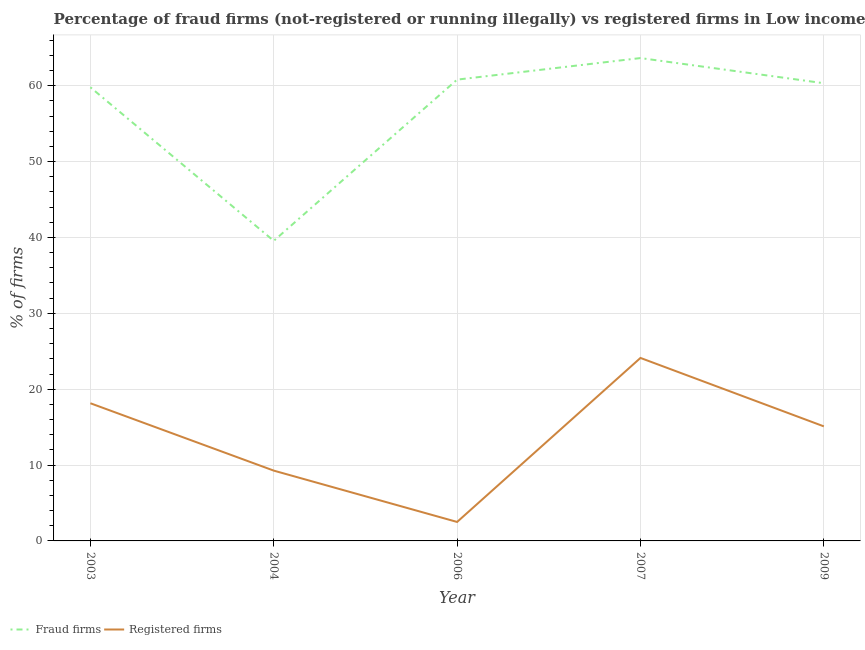How many different coloured lines are there?
Ensure brevity in your answer.  2. Does the line corresponding to percentage of registered firms intersect with the line corresponding to percentage of fraud firms?
Your answer should be compact. No. Across all years, what is the maximum percentage of registered firms?
Your response must be concise. 24.12. Across all years, what is the minimum percentage of fraud firms?
Provide a short and direct response. 39.55. In which year was the percentage of fraud firms maximum?
Provide a succinct answer. 2007. What is the total percentage of fraud firms in the graph?
Keep it short and to the point. 284.1. What is the difference between the percentage of fraud firms in 2003 and that in 2007?
Your response must be concise. -3.85. What is the difference between the percentage of fraud firms in 2004 and the percentage of registered firms in 2006?
Your answer should be compact. 37.05. What is the average percentage of fraud firms per year?
Make the answer very short. 56.82. In the year 2004, what is the difference between the percentage of registered firms and percentage of fraud firms?
Your answer should be very brief. -30.28. What is the ratio of the percentage of fraud firms in 2006 to that in 2007?
Make the answer very short. 0.96. Is the difference between the percentage of registered firms in 2004 and 2007 greater than the difference between the percentage of fraud firms in 2004 and 2007?
Your answer should be compact. Yes. What is the difference between the highest and the second highest percentage of registered firms?
Provide a short and direct response. 5.97. What is the difference between the highest and the lowest percentage of fraud firms?
Offer a very short reply. 24.09. Is the sum of the percentage of registered firms in 2004 and 2006 greater than the maximum percentage of fraud firms across all years?
Offer a very short reply. No. Does the percentage of registered firms monotonically increase over the years?
Your answer should be very brief. No. How many years are there in the graph?
Your response must be concise. 5. What is the difference between two consecutive major ticks on the Y-axis?
Your response must be concise. 10. Are the values on the major ticks of Y-axis written in scientific E-notation?
Offer a very short reply. No. How many legend labels are there?
Provide a short and direct response. 2. What is the title of the graph?
Provide a short and direct response. Percentage of fraud firms (not-registered or running illegally) vs registered firms in Low income. What is the label or title of the Y-axis?
Provide a short and direct response. % of firms. What is the % of firms of Fraud firms in 2003?
Provide a short and direct response. 59.79. What is the % of firms of Registered firms in 2003?
Offer a terse response. 18.15. What is the % of firms in Fraud firms in 2004?
Ensure brevity in your answer.  39.55. What is the % of firms of Registered firms in 2004?
Provide a succinct answer. 9.27. What is the % of firms in Fraud firms in 2006?
Your answer should be very brief. 60.8. What is the % of firms of Registered firms in 2006?
Your answer should be compact. 2.5. What is the % of firms of Fraud firms in 2007?
Offer a terse response. 63.64. What is the % of firms in Registered firms in 2007?
Your response must be concise. 24.12. What is the % of firms in Fraud firms in 2009?
Your answer should be very brief. 60.33. What is the % of firms of Registered firms in 2009?
Make the answer very short. 15.1. Across all years, what is the maximum % of firms of Fraud firms?
Your answer should be very brief. 63.64. Across all years, what is the maximum % of firms of Registered firms?
Provide a succinct answer. 24.12. Across all years, what is the minimum % of firms of Fraud firms?
Give a very brief answer. 39.55. Across all years, what is the minimum % of firms in Registered firms?
Ensure brevity in your answer.  2.5. What is the total % of firms of Fraud firms in the graph?
Your answer should be very brief. 284.1. What is the total % of firms of Registered firms in the graph?
Your response must be concise. 69.13. What is the difference between the % of firms in Fraud firms in 2003 and that in 2004?
Provide a succinct answer. 20.24. What is the difference between the % of firms of Registered firms in 2003 and that in 2004?
Make the answer very short. 8.88. What is the difference between the % of firms in Fraud firms in 2003 and that in 2006?
Provide a succinct answer. -1.01. What is the difference between the % of firms in Registered firms in 2003 and that in 2006?
Offer a very short reply. 15.65. What is the difference between the % of firms in Fraud firms in 2003 and that in 2007?
Your answer should be compact. -3.85. What is the difference between the % of firms of Registered firms in 2003 and that in 2007?
Give a very brief answer. -5.97. What is the difference between the % of firms in Fraud firms in 2003 and that in 2009?
Make the answer very short. -0.54. What is the difference between the % of firms of Registered firms in 2003 and that in 2009?
Offer a very short reply. 3.05. What is the difference between the % of firms in Fraud firms in 2004 and that in 2006?
Provide a succinct answer. -21.25. What is the difference between the % of firms of Registered firms in 2004 and that in 2006?
Your answer should be very brief. 6.77. What is the difference between the % of firms in Fraud firms in 2004 and that in 2007?
Provide a succinct answer. -24.09. What is the difference between the % of firms of Registered firms in 2004 and that in 2007?
Your answer should be compact. -14.85. What is the difference between the % of firms of Fraud firms in 2004 and that in 2009?
Provide a succinct answer. -20.77. What is the difference between the % of firms of Registered firms in 2004 and that in 2009?
Your answer should be compact. -5.83. What is the difference between the % of firms of Fraud firms in 2006 and that in 2007?
Make the answer very short. -2.84. What is the difference between the % of firms in Registered firms in 2006 and that in 2007?
Your response must be concise. -21.62. What is the difference between the % of firms in Fraud firms in 2006 and that in 2009?
Ensure brevity in your answer.  0.47. What is the difference between the % of firms in Registered firms in 2006 and that in 2009?
Give a very brief answer. -12.6. What is the difference between the % of firms in Fraud firms in 2007 and that in 2009?
Ensure brevity in your answer.  3.31. What is the difference between the % of firms in Registered firms in 2007 and that in 2009?
Your answer should be very brief. 9.02. What is the difference between the % of firms of Fraud firms in 2003 and the % of firms of Registered firms in 2004?
Ensure brevity in your answer.  50.52. What is the difference between the % of firms in Fraud firms in 2003 and the % of firms in Registered firms in 2006?
Provide a succinct answer. 57.29. What is the difference between the % of firms of Fraud firms in 2003 and the % of firms of Registered firms in 2007?
Your answer should be very brief. 35.67. What is the difference between the % of firms of Fraud firms in 2003 and the % of firms of Registered firms in 2009?
Provide a succinct answer. 44.69. What is the difference between the % of firms in Fraud firms in 2004 and the % of firms in Registered firms in 2006?
Your answer should be very brief. 37.05. What is the difference between the % of firms of Fraud firms in 2004 and the % of firms of Registered firms in 2007?
Make the answer very short. 15.43. What is the difference between the % of firms of Fraud firms in 2004 and the % of firms of Registered firms in 2009?
Make the answer very short. 24.45. What is the difference between the % of firms of Fraud firms in 2006 and the % of firms of Registered firms in 2007?
Provide a short and direct response. 36.68. What is the difference between the % of firms of Fraud firms in 2006 and the % of firms of Registered firms in 2009?
Your answer should be very brief. 45.7. What is the difference between the % of firms in Fraud firms in 2007 and the % of firms in Registered firms in 2009?
Provide a short and direct response. 48.54. What is the average % of firms in Fraud firms per year?
Your response must be concise. 56.82. What is the average % of firms in Registered firms per year?
Ensure brevity in your answer.  13.83. In the year 2003, what is the difference between the % of firms of Fraud firms and % of firms of Registered firms?
Your response must be concise. 41.64. In the year 2004, what is the difference between the % of firms of Fraud firms and % of firms of Registered firms?
Your answer should be compact. 30.28. In the year 2006, what is the difference between the % of firms of Fraud firms and % of firms of Registered firms?
Your answer should be very brief. 58.3. In the year 2007, what is the difference between the % of firms of Fraud firms and % of firms of Registered firms?
Provide a succinct answer. 39.52. In the year 2009, what is the difference between the % of firms of Fraud firms and % of firms of Registered firms?
Provide a succinct answer. 45.23. What is the ratio of the % of firms of Fraud firms in 2003 to that in 2004?
Keep it short and to the point. 1.51. What is the ratio of the % of firms of Registered firms in 2003 to that in 2004?
Give a very brief answer. 1.96. What is the ratio of the % of firms of Fraud firms in 2003 to that in 2006?
Give a very brief answer. 0.98. What is the ratio of the % of firms in Registered firms in 2003 to that in 2006?
Your answer should be compact. 7.26. What is the ratio of the % of firms of Fraud firms in 2003 to that in 2007?
Your response must be concise. 0.94. What is the ratio of the % of firms of Registered firms in 2003 to that in 2007?
Provide a succinct answer. 0.75. What is the ratio of the % of firms in Registered firms in 2003 to that in 2009?
Offer a terse response. 1.2. What is the ratio of the % of firms in Fraud firms in 2004 to that in 2006?
Keep it short and to the point. 0.65. What is the ratio of the % of firms of Registered firms in 2004 to that in 2006?
Keep it short and to the point. 3.71. What is the ratio of the % of firms of Fraud firms in 2004 to that in 2007?
Your response must be concise. 0.62. What is the ratio of the % of firms of Registered firms in 2004 to that in 2007?
Offer a very short reply. 0.38. What is the ratio of the % of firms in Fraud firms in 2004 to that in 2009?
Your answer should be very brief. 0.66. What is the ratio of the % of firms of Registered firms in 2004 to that in 2009?
Keep it short and to the point. 0.61. What is the ratio of the % of firms of Fraud firms in 2006 to that in 2007?
Offer a terse response. 0.96. What is the ratio of the % of firms in Registered firms in 2006 to that in 2007?
Your response must be concise. 0.1. What is the ratio of the % of firms in Fraud firms in 2006 to that in 2009?
Ensure brevity in your answer.  1.01. What is the ratio of the % of firms in Registered firms in 2006 to that in 2009?
Make the answer very short. 0.17. What is the ratio of the % of firms in Fraud firms in 2007 to that in 2009?
Provide a succinct answer. 1.05. What is the ratio of the % of firms of Registered firms in 2007 to that in 2009?
Offer a terse response. 1.6. What is the difference between the highest and the second highest % of firms in Fraud firms?
Ensure brevity in your answer.  2.84. What is the difference between the highest and the second highest % of firms of Registered firms?
Provide a short and direct response. 5.97. What is the difference between the highest and the lowest % of firms in Fraud firms?
Give a very brief answer. 24.09. What is the difference between the highest and the lowest % of firms of Registered firms?
Provide a succinct answer. 21.62. 